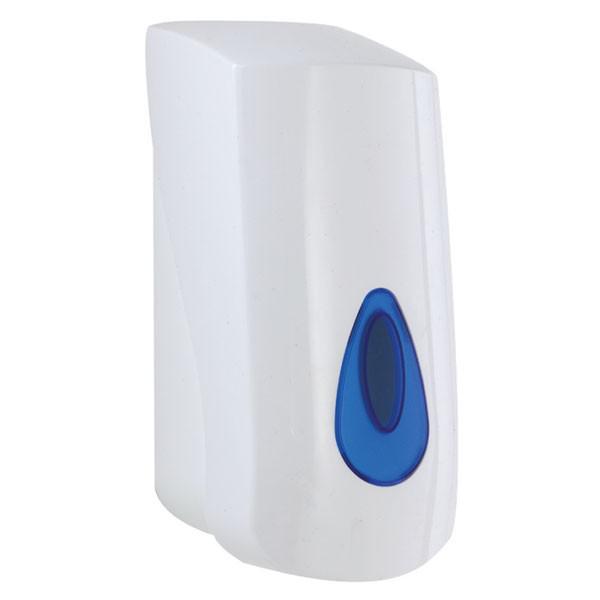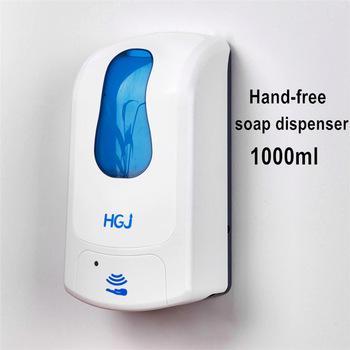The first image is the image on the left, the second image is the image on the right. For the images shown, is this caption "At least one image includes a chrome-finish dispenser." true? Answer yes or no. No. 